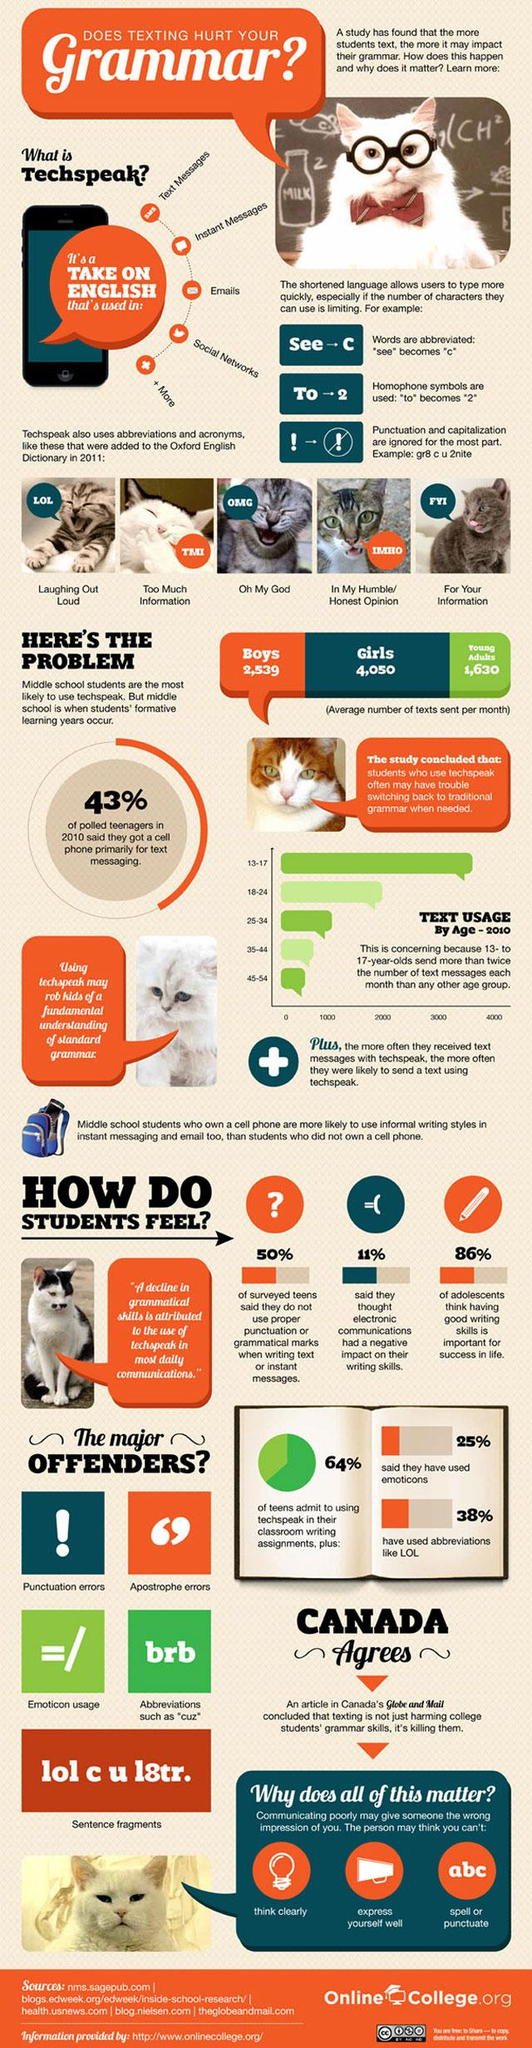Outline some significant characteristics in this image. The Globe and Mail is mentioned in the text. The 18-24 age group is the second largest in terms of text usage. 